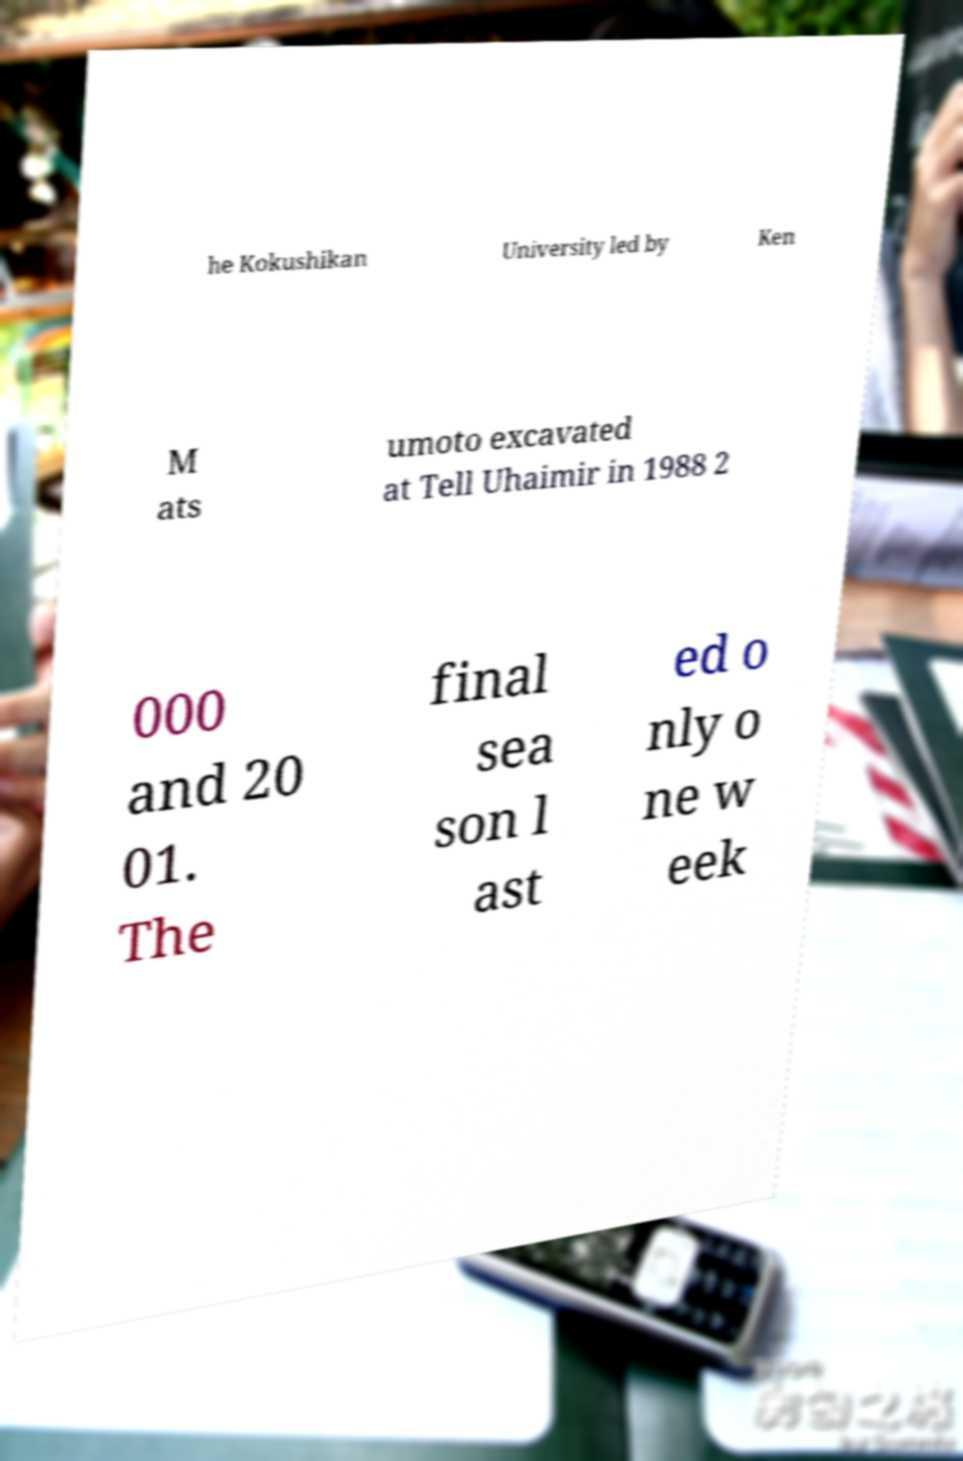Please identify and transcribe the text found in this image. he Kokushikan University led by Ken M ats umoto excavated at Tell Uhaimir in 1988 2 000 and 20 01. The final sea son l ast ed o nly o ne w eek 